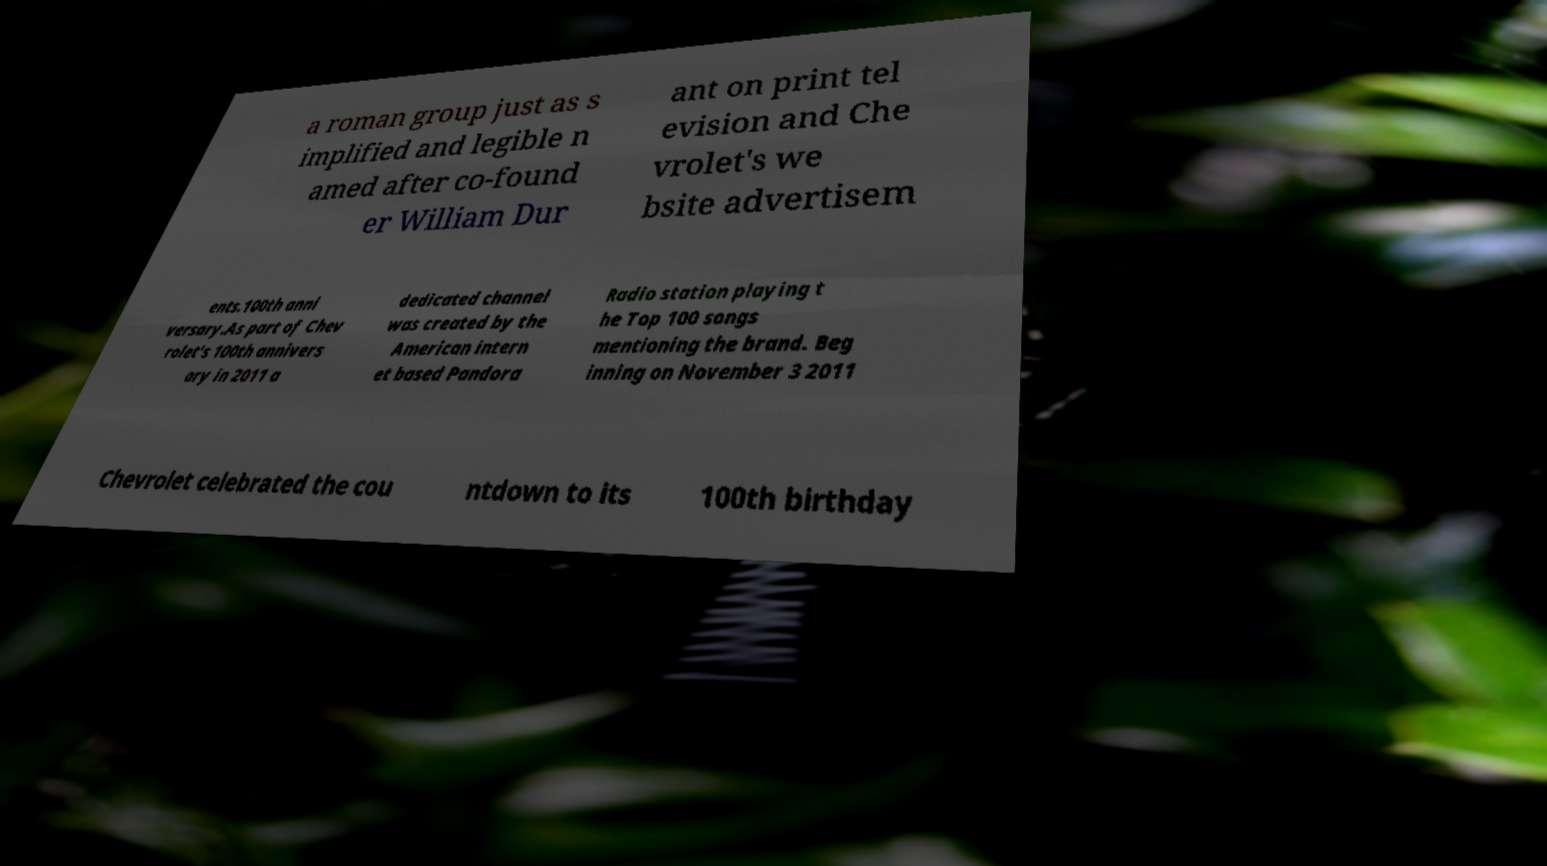Could you assist in decoding the text presented in this image and type it out clearly? a roman group just as s implified and legible n amed after co-found er William Dur ant on print tel evision and Che vrolet's we bsite advertisem ents.100th anni versary.As part of Chev rolet's 100th annivers ary in 2011 a dedicated channel was created by the American intern et based Pandora Radio station playing t he Top 100 songs mentioning the brand. Beg inning on November 3 2011 Chevrolet celebrated the cou ntdown to its 100th birthday 